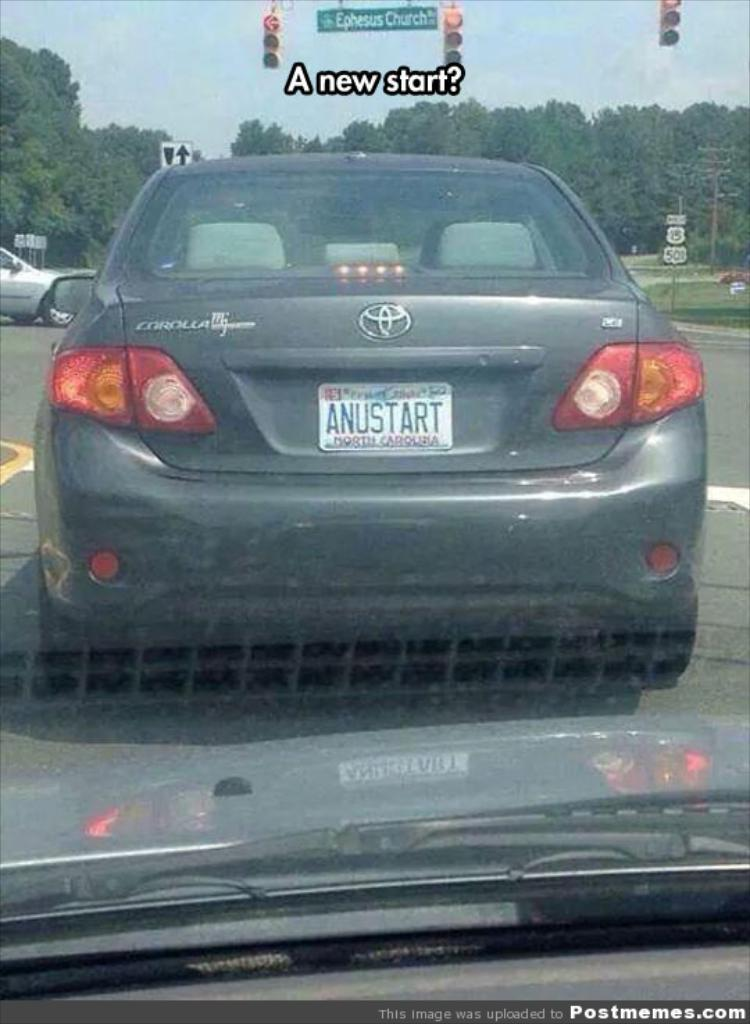Provide a one-sentence caption for the provided image. A gray Corolla waits at a stop light showing a red arrow. 